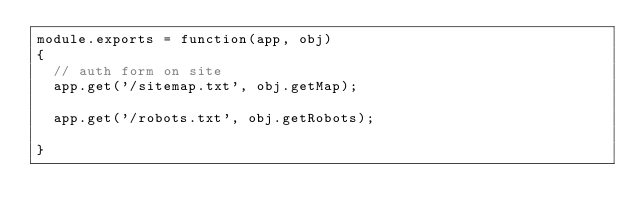<code> <loc_0><loc_0><loc_500><loc_500><_JavaScript_>module.exports = function(app, obj)
{
  // auth form on site
  app.get('/sitemap.txt', obj.getMap);

  app.get('/robots.txt', obj.getRobots);

}
</code> 